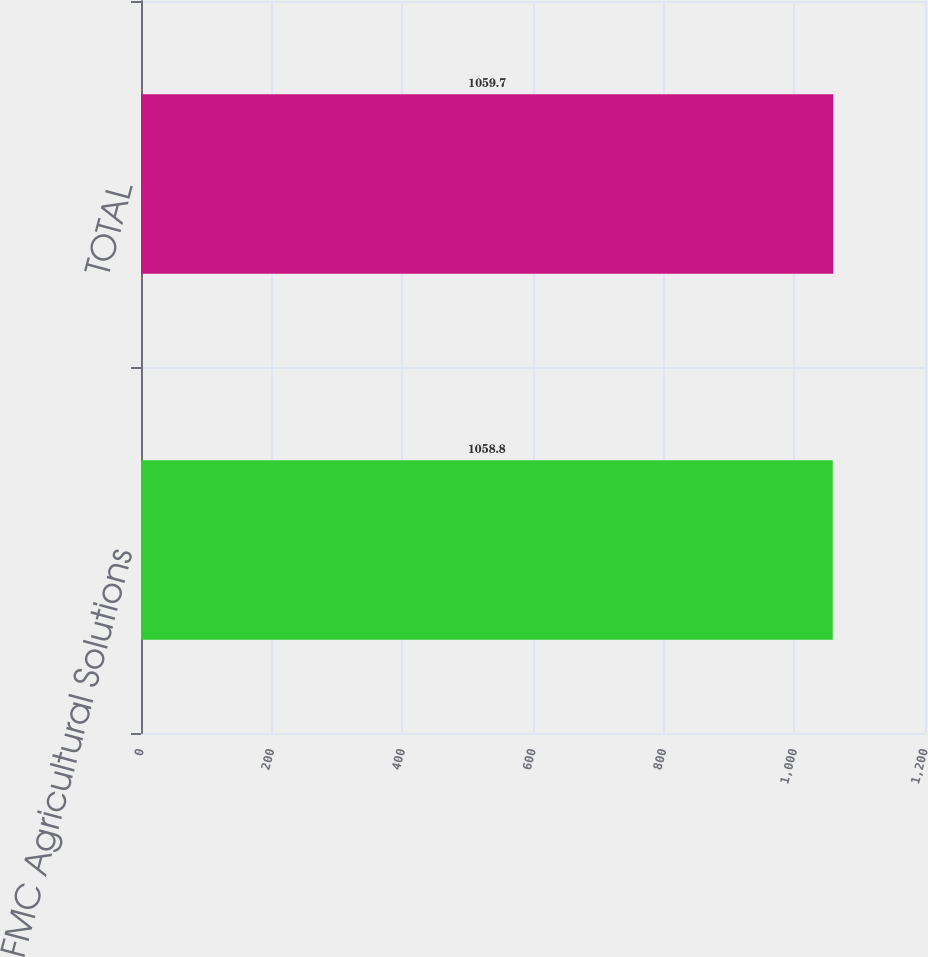Convert chart to OTSL. <chart><loc_0><loc_0><loc_500><loc_500><bar_chart><fcel>FMC Agricultural Solutions<fcel>TOTAL<nl><fcel>1058.8<fcel>1059.7<nl></chart> 